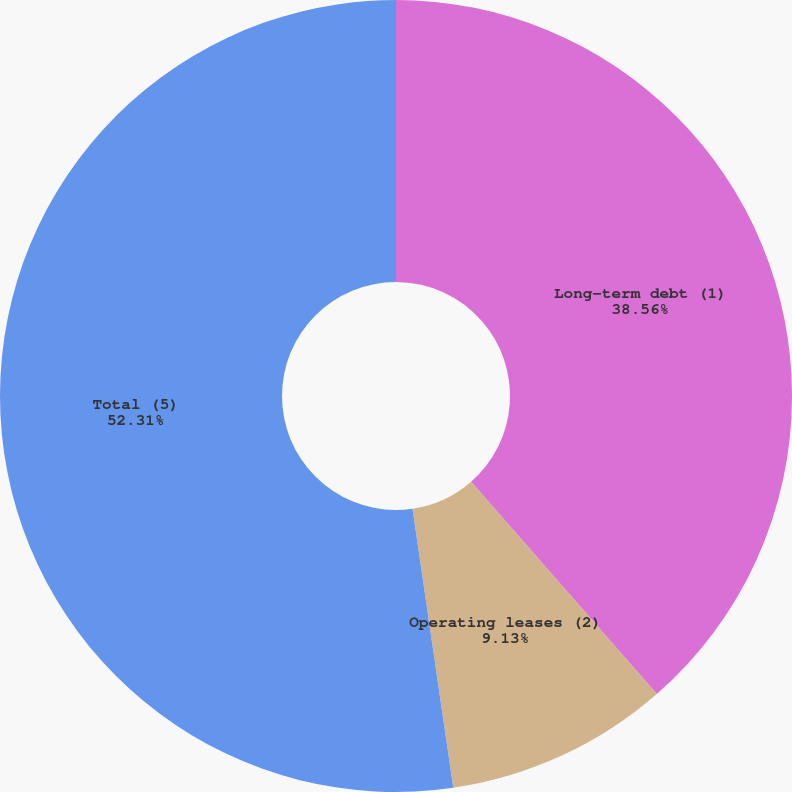<chart> <loc_0><loc_0><loc_500><loc_500><pie_chart><fcel>Long-term debt (1)<fcel>Operating leases (2)<fcel>Total (5)<nl><fcel>38.56%<fcel>9.13%<fcel>52.31%<nl></chart> 